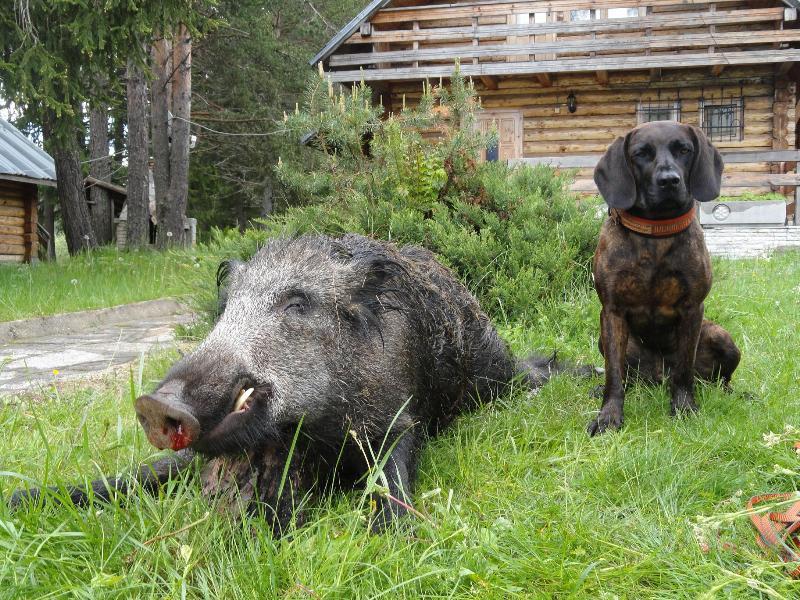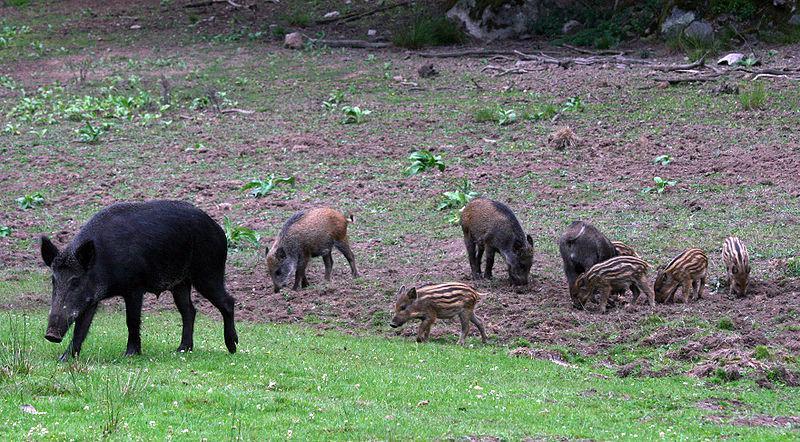The first image is the image on the left, the second image is the image on the right. Analyze the images presented: Is the assertion "On one image features one dog near a pig." valid? Answer yes or no. Yes. 